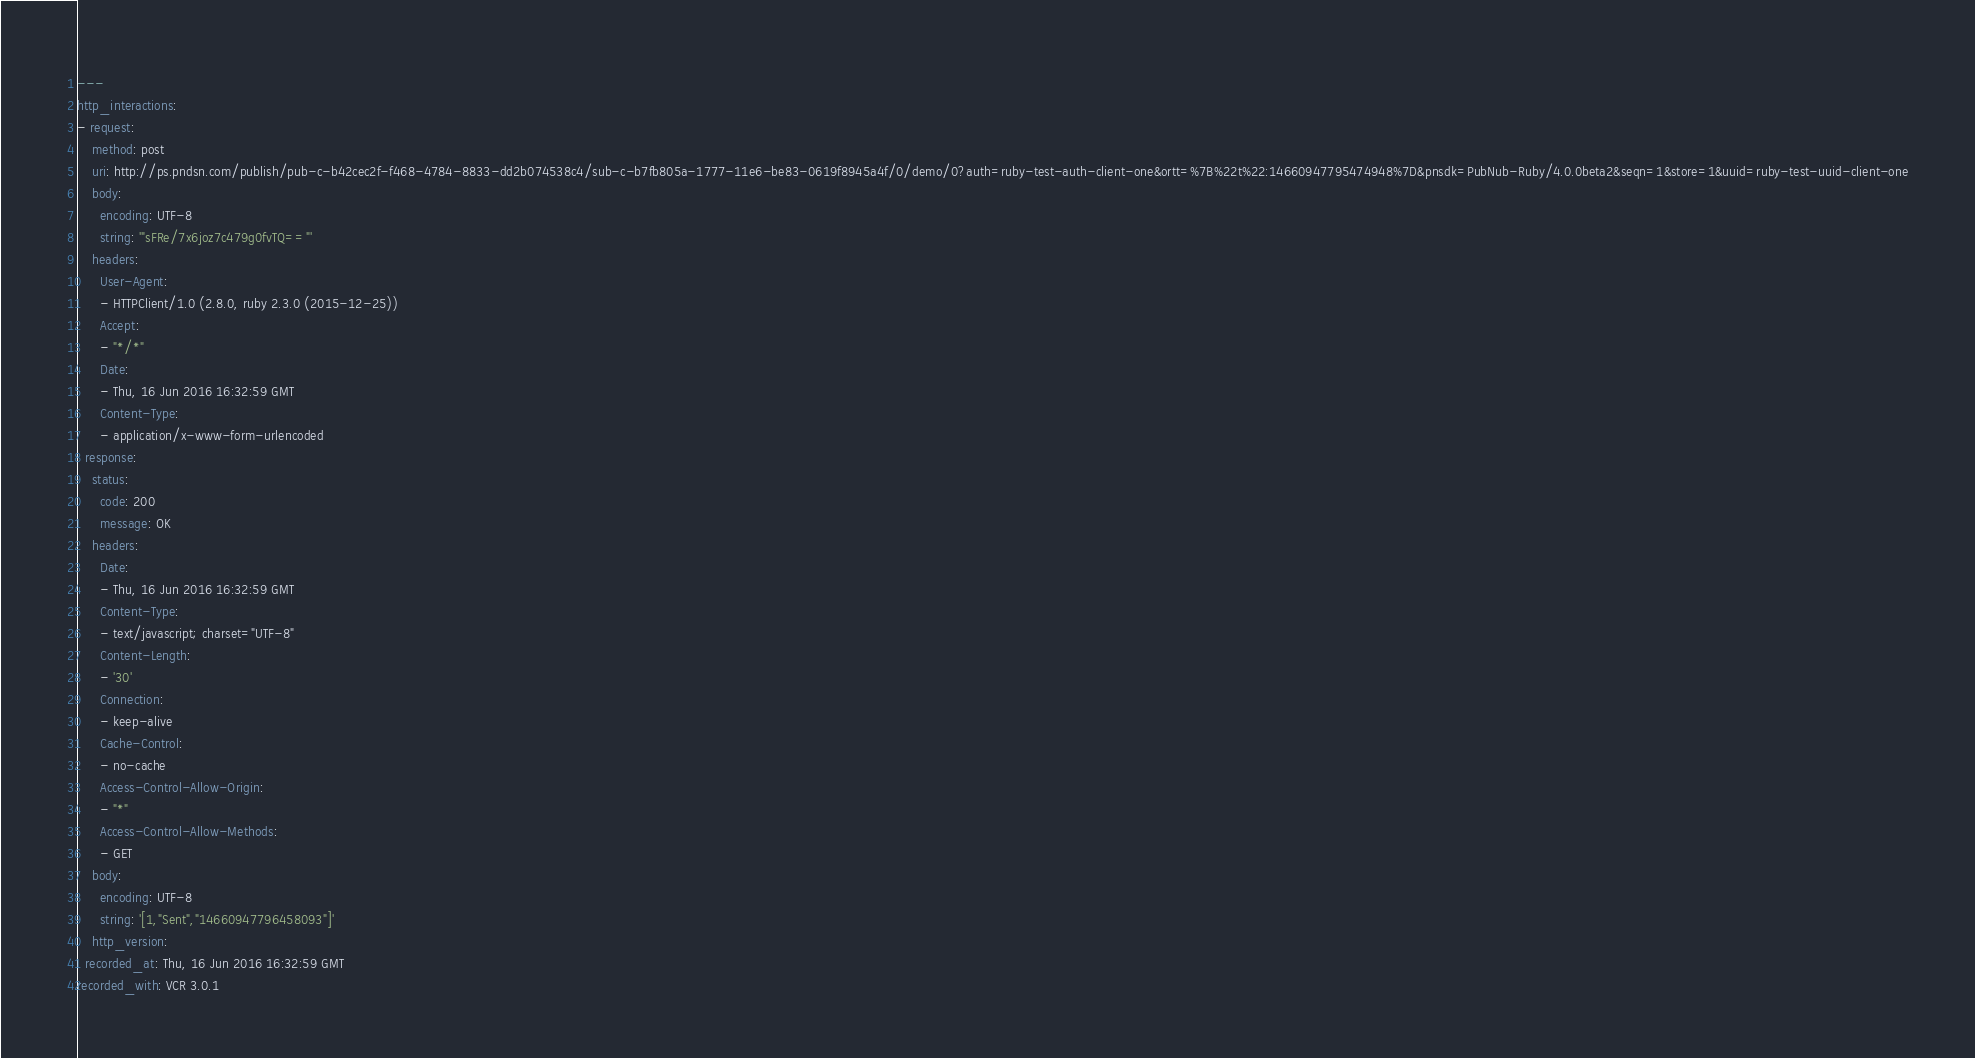<code> <loc_0><loc_0><loc_500><loc_500><_YAML_>---
http_interactions:
- request:
    method: post
    uri: http://ps.pndsn.com/publish/pub-c-b42cec2f-f468-4784-8833-dd2b074538c4/sub-c-b7fb805a-1777-11e6-be83-0619f8945a4f/0/demo/0?auth=ruby-test-auth-client-one&ortt=%7B%22t%22:14660947795474948%7D&pnsdk=PubNub-Ruby/4.0.0beta2&seqn=1&store=1&uuid=ruby-test-uuid-client-one
    body:
      encoding: UTF-8
      string: '"sFRe/7x6joz7c479g0fvTQ=="'
    headers:
      User-Agent:
      - HTTPClient/1.0 (2.8.0, ruby 2.3.0 (2015-12-25))
      Accept:
      - "*/*"
      Date:
      - Thu, 16 Jun 2016 16:32:59 GMT
      Content-Type:
      - application/x-www-form-urlencoded
  response:
    status:
      code: 200
      message: OK
    headers:
      Date:
      - Thu, 16 Jun 2016 16:32:59 GMT
      Content-Type:
      - text/javascript; charset="UTF-8"
      Content-Length:
      - '30'
      Connection:
      - keep-alive
      Cache-Control:
      - no-cache
      Access-Control-Allow-Origin:
      - "*"
      Access-Control-Allow-Methods:
      - GET
    body:
      encoding: UTF-8
      string: '[1,"Sent","14660947796458093"]'
    http_version: 
  recorded_at: Thu, 16 Jun 2016 16:32:59 GMT
recorded_with: VCR 3.0.1
</code> 